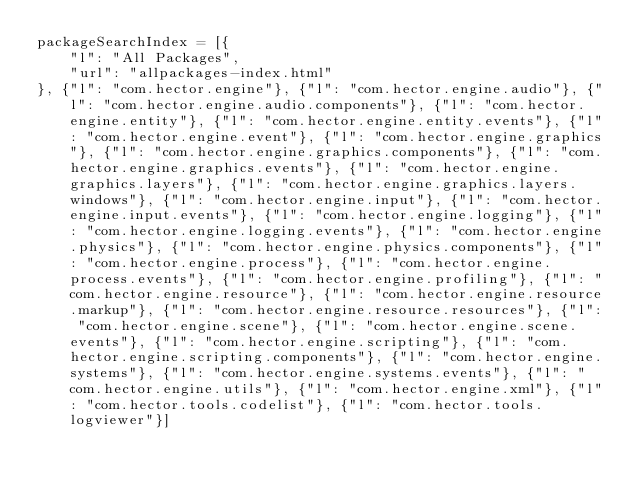Convert code to text. <code><loc_0><loc_0><loc_500><loc_500><_JavaScript_>packageSearchIndex = [{
    "l": "All Packages",
    "url": "allpackages-index.html"
}, {"l": "com.hector.engine"}, {"l": "com.hector.engine.audio"}, {"l": "com.hector.engine.audio.components"}, {"l": "com.hector.engine.entity"}, {"l": "com.hector.engine.entity.events"}, {"l": "com.hector.engine.event"}, {"l": "com.hector.engine.graphics"}, {"l": "com.hector.engine.graphics.components"}, {"l": "com.hector.engine.graphics.events"}, {"l": "com.hector.engine.graphics.layers"}, {"l": "com.hector.engine.graphics.layers.windows"}, {"l": "com.hector.engine.input"}, {"l": "com.hector.engine.input.events"}, {"l": "com.hector.engine.logging"}, {"l": "com.hector.engine.logging.events"}, {"l": "com.hector.engine.physics"}, {"l": "com.hector.engine.physics.components"}, {"l": "com.hector.engine.process"}, {"l": "com.hector.engine.process.events"}, {"l": "com.hector.engine.profiling"}, {"l": "com.hector.engine.resource"}, {"l": "com.hector.engine.resource.markup"}, {"l": "com.hector.engine.resource.resources"}, {"l": "com.hector.engine.scene"}, {"l": "com.hector.engine.scene.events"}, {"l": "com.hector.engine.scripting"}, {"l": "com.hector.engine.scripting.components"}, {"l": "com.hector.engine.systems"}, {"l": "com.hector.engine.systems.events"}, {"l": "com.hector.engine.utils"}, {"l": "com.hector.engine.xml"}, {"l": "com.hector.tools.codelist"}, {"l": "com.hector.tools.logviewer"}]</code> 